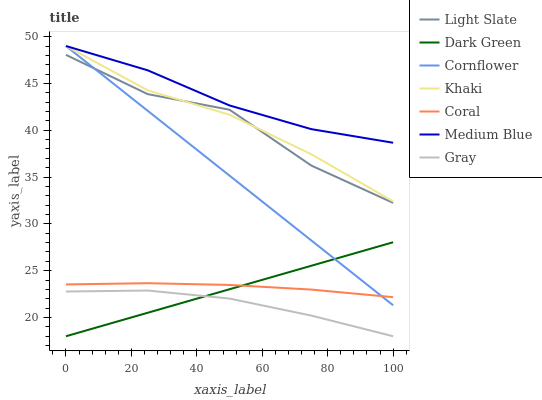Does Gray have the minimum area under the curve?
Answer yes or no. Yes. Does Medium Blue have the maximum area under the curve?
Answer yes or no. Yes. Does Khaki have the minimum area under the curve?
Answer yes or no. No. Does Khaki have the maximum area under the curve?
Answer yes or no. No. Is Dark Green the smoothest?
Answer yes or no. Yes. Is Light Slate the roughest?
Answer yes or no. Yes. Is Khaki the smoothest?
Answer yes or no. No. Is Khaki the roughest?
Answer yes or no. No. Does Gray have the lowest value?
Answer yes or no. Yes. Does Khaki have the lowest value?
Answer yes or no. No. Does Medium Blue have the highest value?
Answer yes or no. Yes. Does Gray have the highest value?
Answer yes or no. No. Is Coral less than Medium Blue?
Answer yes or no. Yes. Is Light Slate greater than Coral?
Answer yes or no. Yes. Does Khaki intersect Cornflower?
Answer yes or no. Yes. Is Khaki less than Cornflower?
Answer yes or no. No. Is Khaki greater than Cornflower?
Answer yes or no. No. Does Coral intersect Medium Blue?
Answer yes or no. No. 